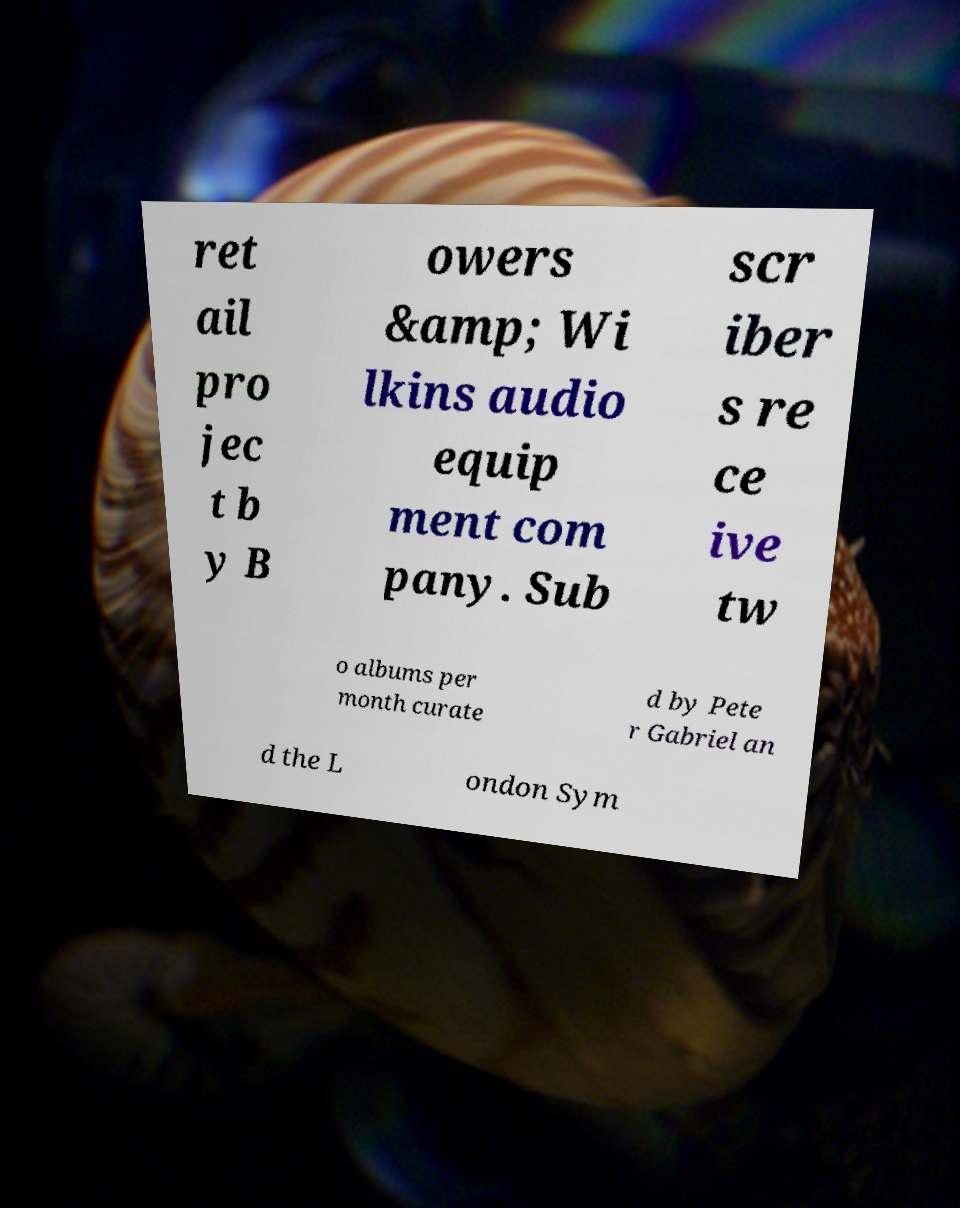For documentation purposes, I need the text within this image transcribed. Could you provide that? ret ail pro jec t b y B owers &amp; Wi lkins audio equip ment com pany. Sub scr iber s re ce ive tw o albums per month curate d by Pete r Gabriel an d the L ondon Sym 